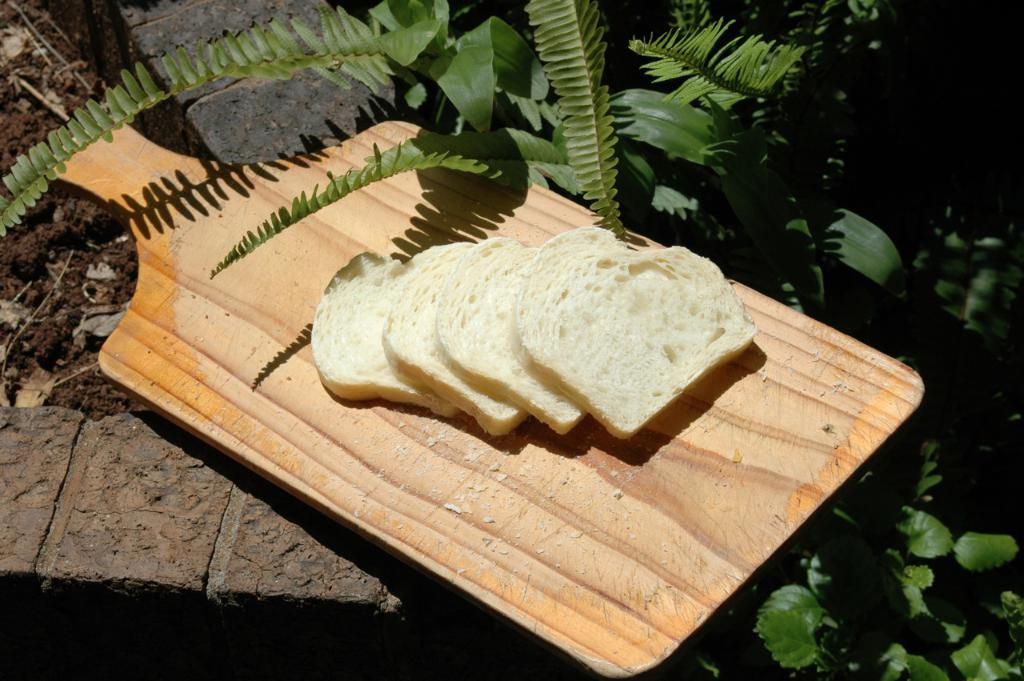What type of food is on the plate in the image? There are pieces of bread on a brown color plate in the image. What can be seen in the image besides the plate and bread? Plants are visible in the image. What is the color of the mud on the left side of the image? The mud on the left side of the image is brown. Who is the expert responsible for creating the mud in the image? There is no expert or creator mentioned in the image, and the mud is a natural occurrence. 